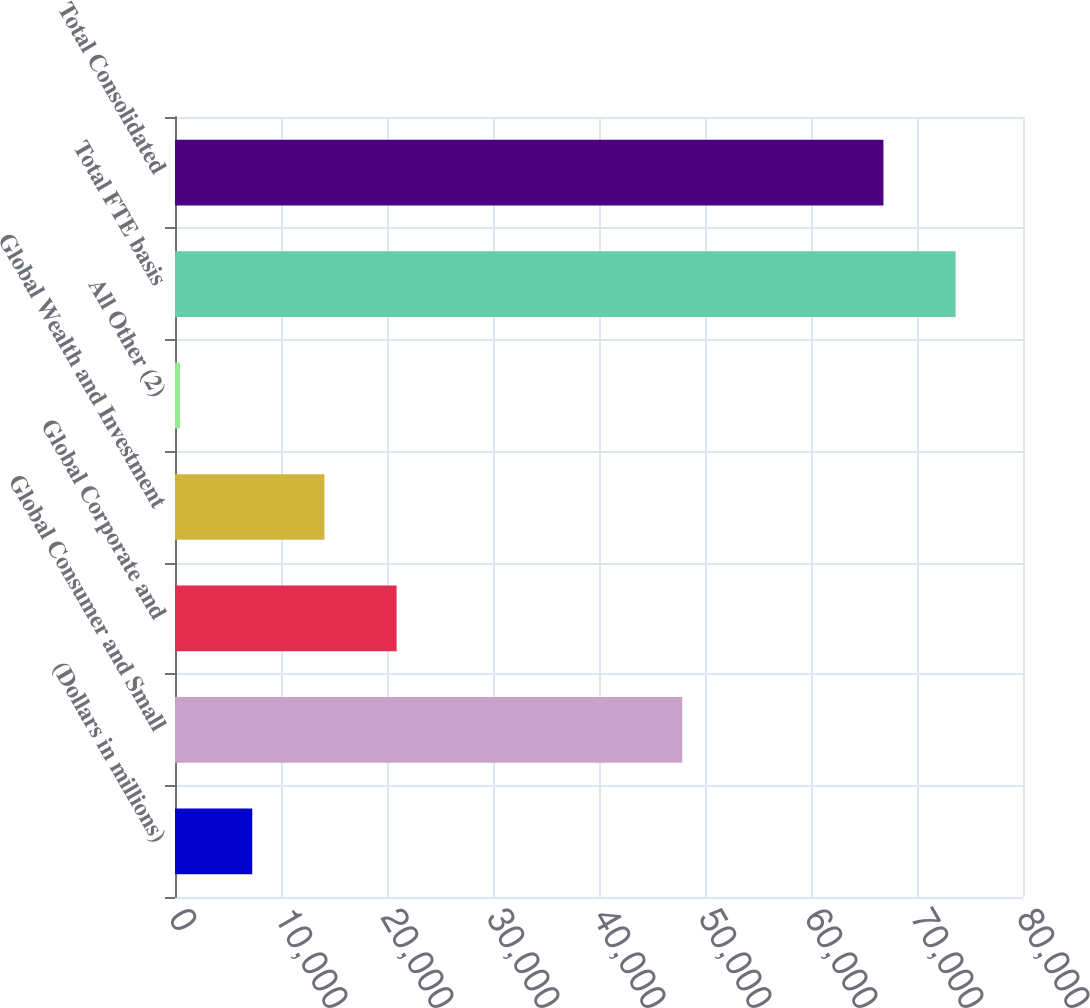<chart> <loc_0><loc_0><loc_500><loc_500><bar_chart><fcel>(Dollars in millions)<fcel>Global Consumer and Small<fcel>Global Corporate and<fcel>Global Wealth and Investment<fcel>All Other (2)<fcel>Total FTE basis<fcel>Total Consolidated<nl><fcel>7287.5<fcel>47855<fcel>20908.5<fcel>14098<fcel>477<fcel>73643.5<fcel>66833<nl></chart> 